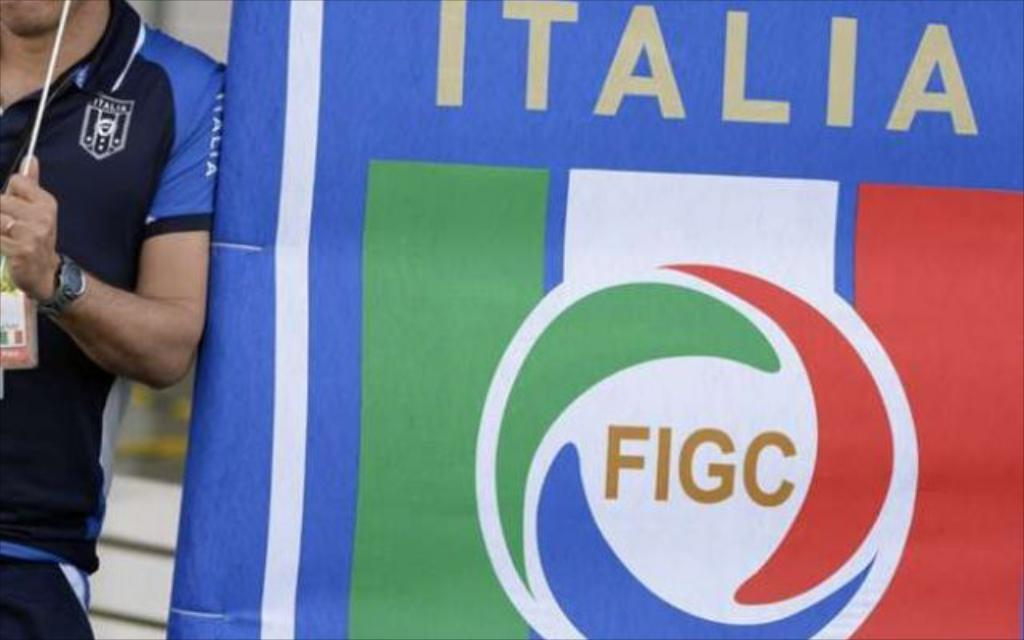<image>
Summarize the visual content of the image. A man leans against an ITALIA FIGC banner hanging on a wall. 